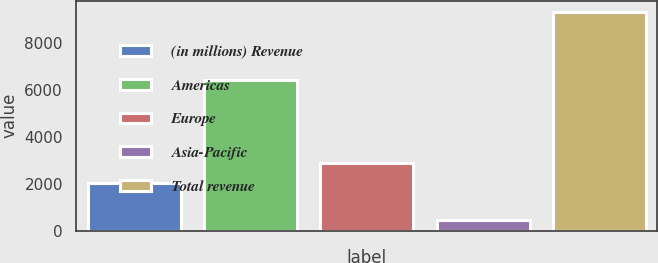Convert chart to OTSL. <chart><loc_0><loc_0><loc_500><loc_500><bar_chart><fcel>(in millions) Revenue<fcel>Americas<fcel>Europe<fcel>Asia-Pacific<fcel>Total revenue<nl><fcel>2012<fcel>6429<fcel>2900.9<fcel>448<fcel>9337<nl></chart> 